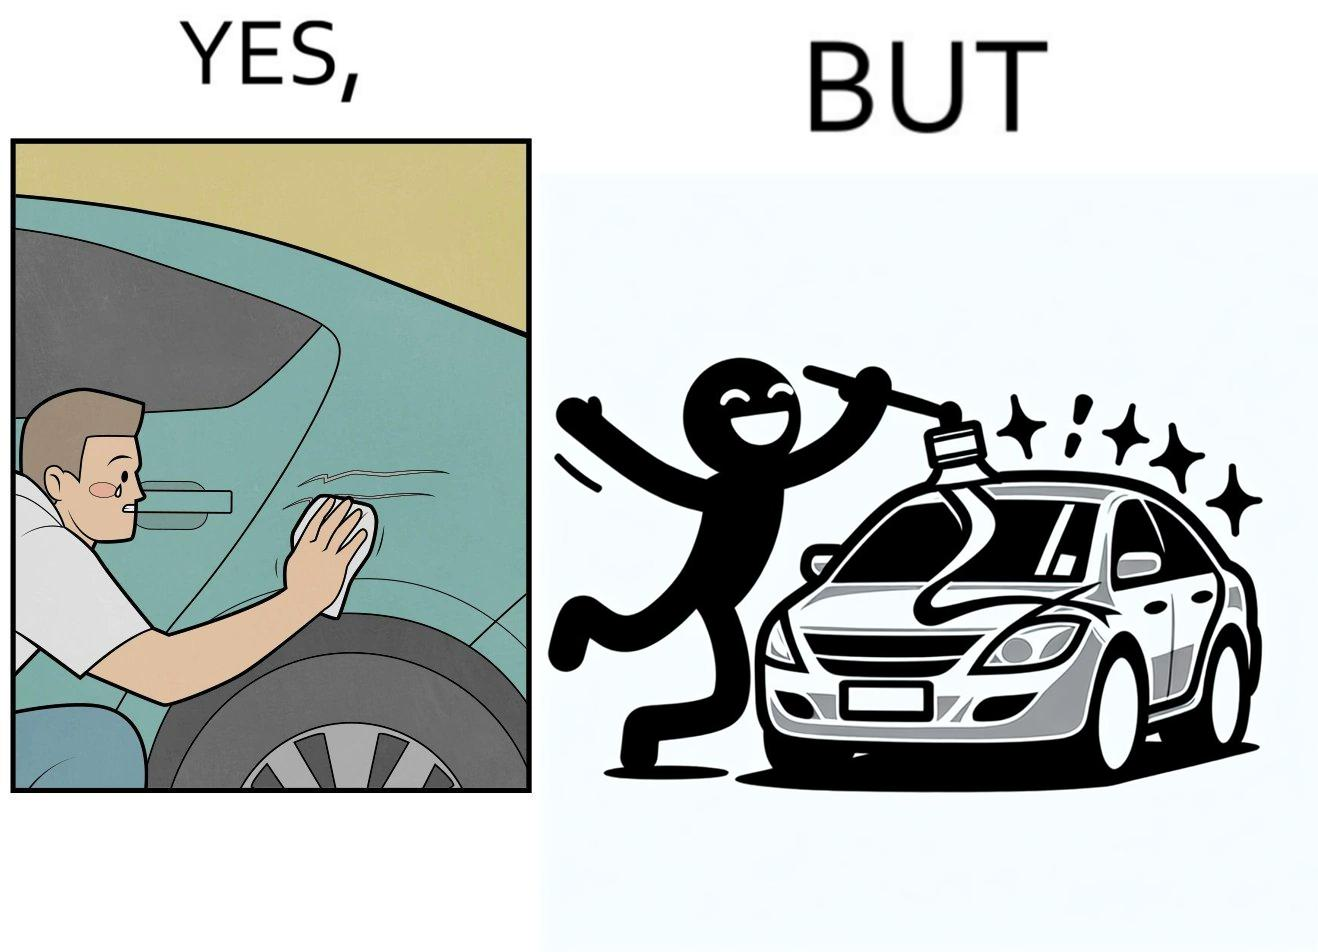Explain why this image is satirical. The image is ironic, because the person who cries over the scratches on his car but applies stickers on his car happily which is quite dual nature of the person 